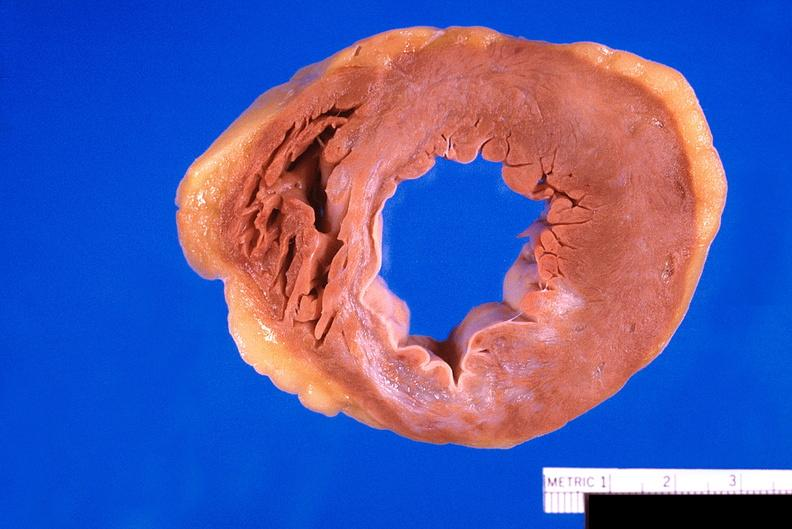does metastatic carcinoma show heart, old myocardial infarction with fibrosis?
Answer the question using a single word or phrase. No 